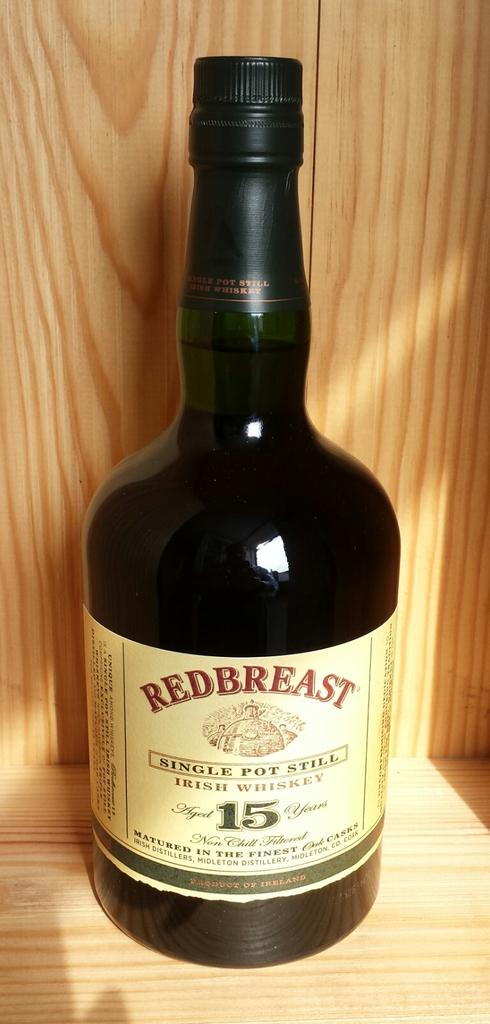<image>
Share a concise interpretation of the image provided. A bottle of liquor that says Redbreast is on a wooden shelf. 